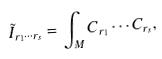Convert formula to latex. <formula><loc_0><loc_0><loc_500><loc_500>\tilde { I } _ { r _ { 1 } \cdots r _ { s } } = \int _ { M } C _ { r _ { 1 } } \cdots C _ { r _ { s } } ,</formula> 